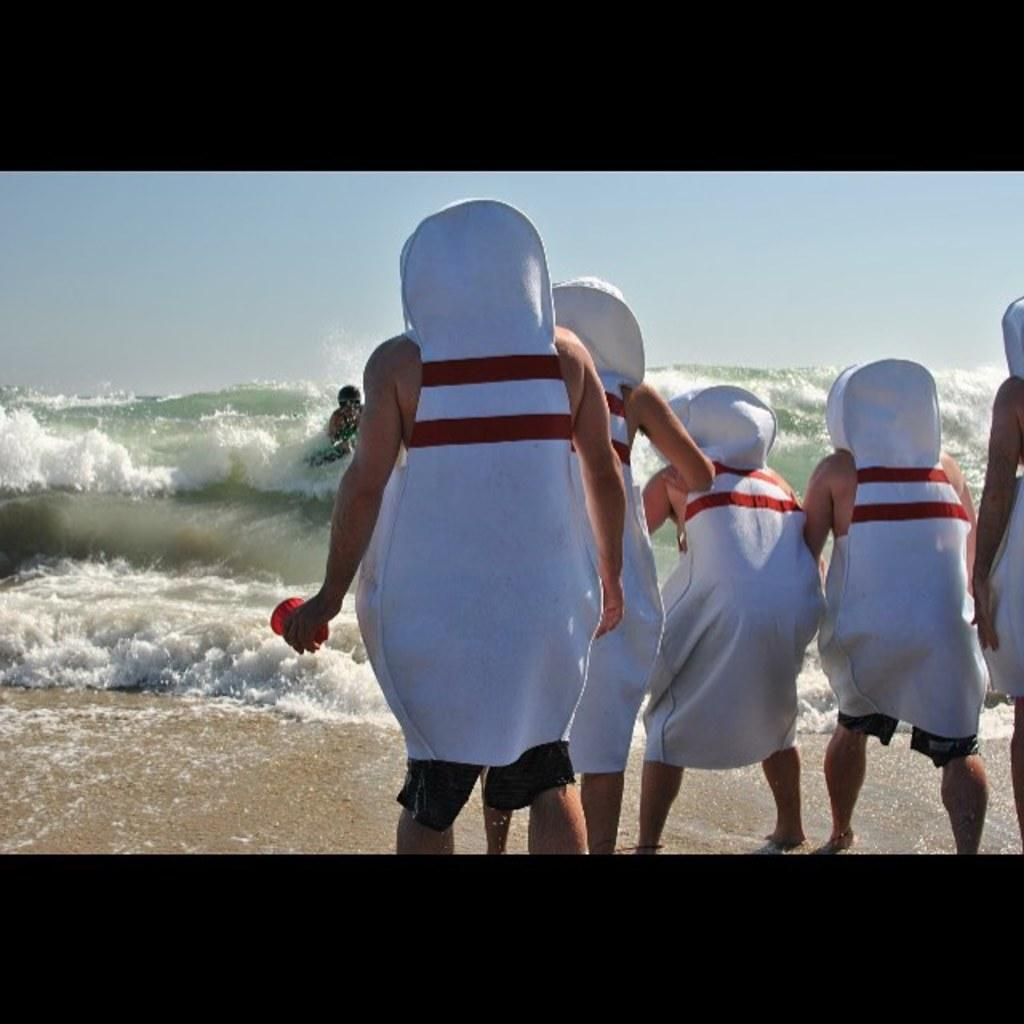Who or what is present in the image? There are people in the image. What are the people wearing? The people are wearing the same costume. What natural element can be seen in the image? There is water visible in the image. What part of the natural environment is visible in the image? The sky is visible in the image. What type of metal can be seen in the image? There is no metal present in the image. What animal is visible in the image? There are no animals visible in the image; it features people wearing costumes. 